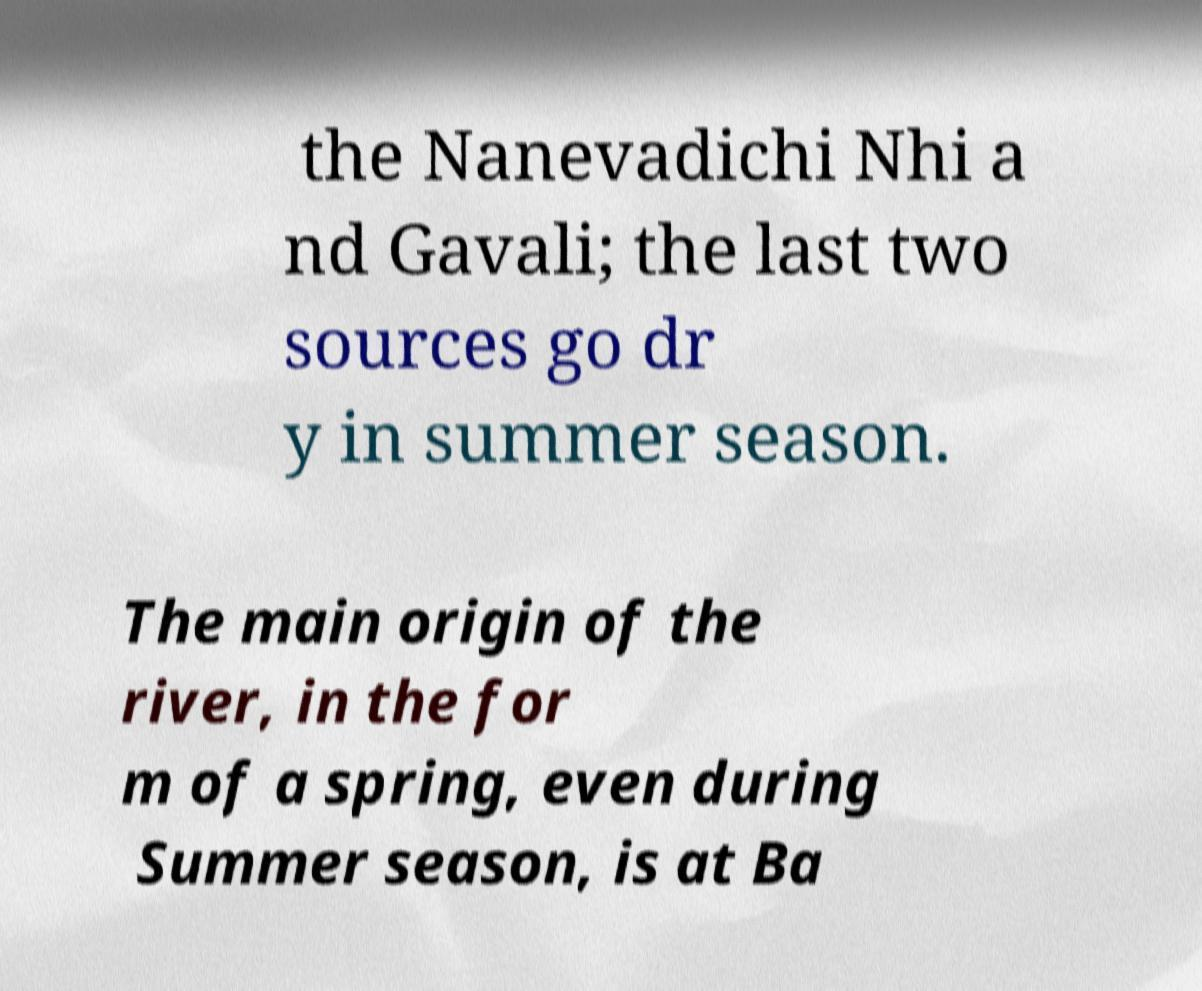Please identify and transcribe the text found in this image. the Nanevadichi Nhi a nd Gavali; the last two sources go dr y in summer season. The main origin of the river, in the for m of a spring, even during Summer season, is at Ba 